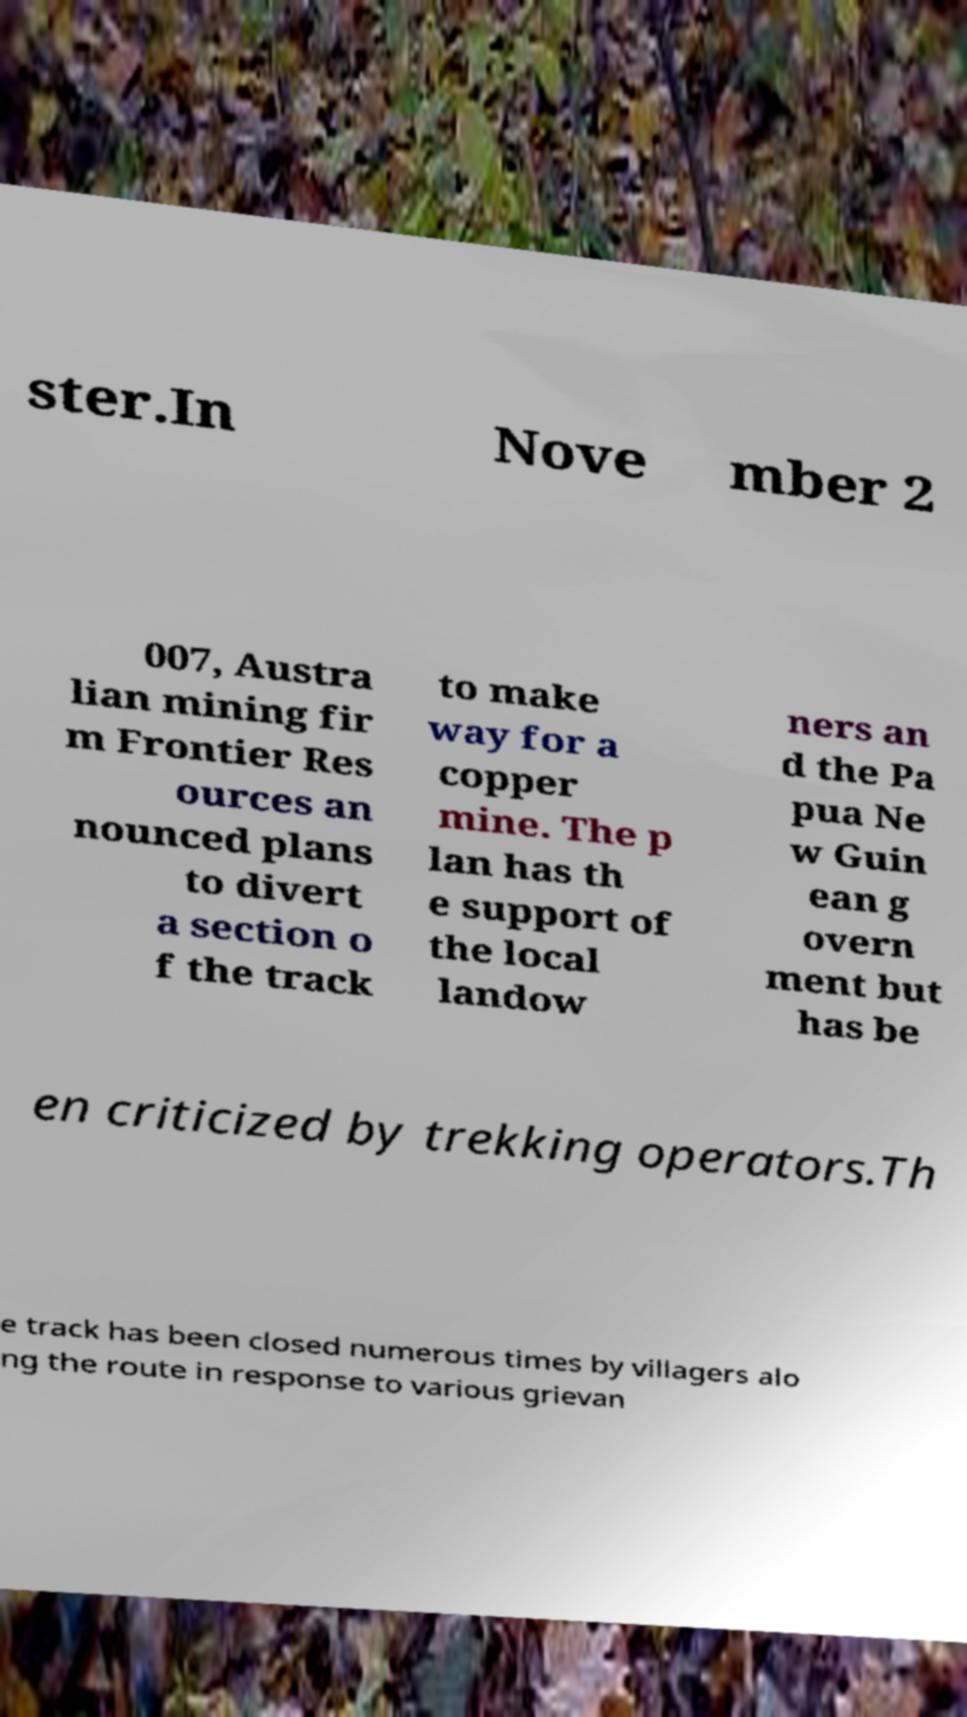Please identify and transcribe the text found in this image. ster.In Nove mber 2 007, Austra lian mining fir m Frontier Res ources an nounced plans to divert a section o f the track to make way for a copper mine. The p lan has th e support of the local landow ners an d the Pa pua Ne w Guin ean g overn ment but has be en criticized by trekking operators.Th e track has been closed numerous times by villagers alo ng the route in response to various grievan 